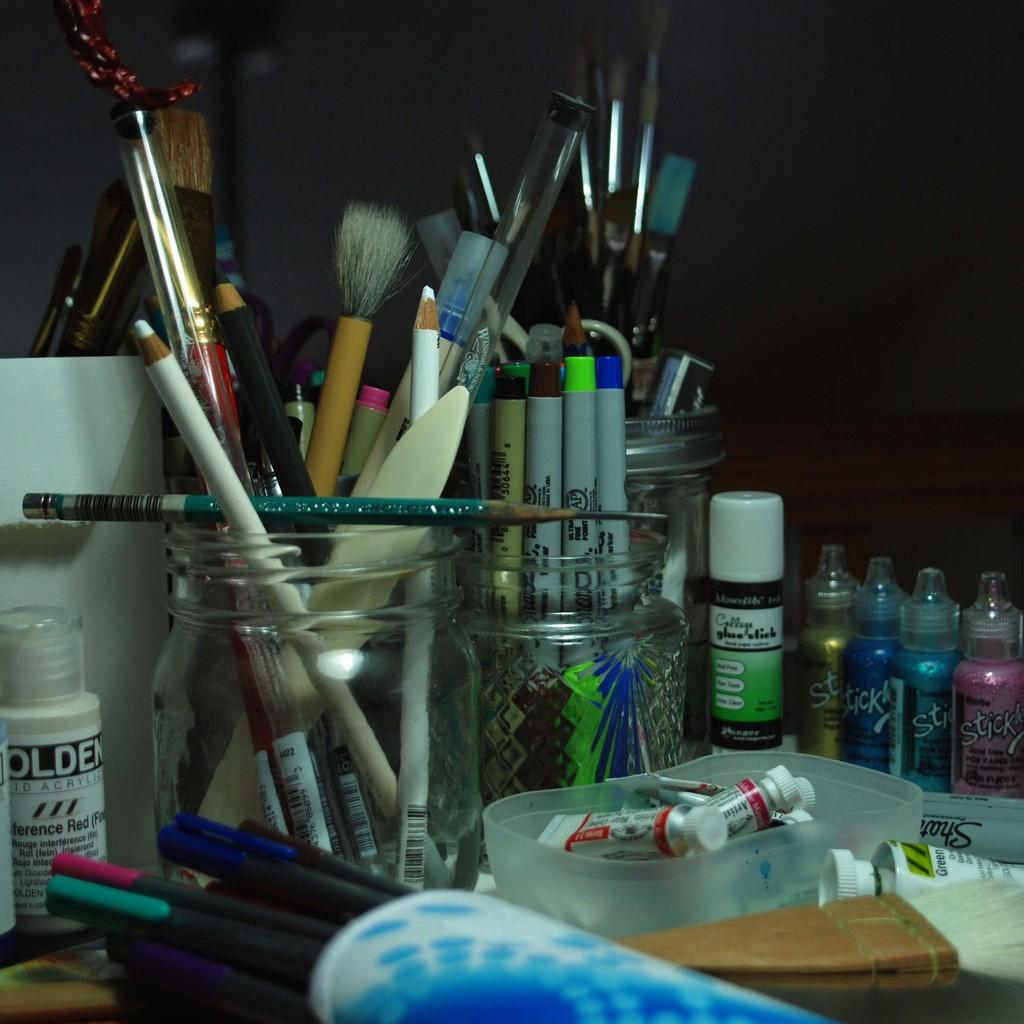<image>
Relay a brief, clear account of the picture shown. A multitude of different art supplies are in jars, next to bottles of colored Sticky glue. 